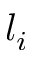<formula> <loc_0><loc_0><loc_500><loc_500>l _ { i }</formula> 